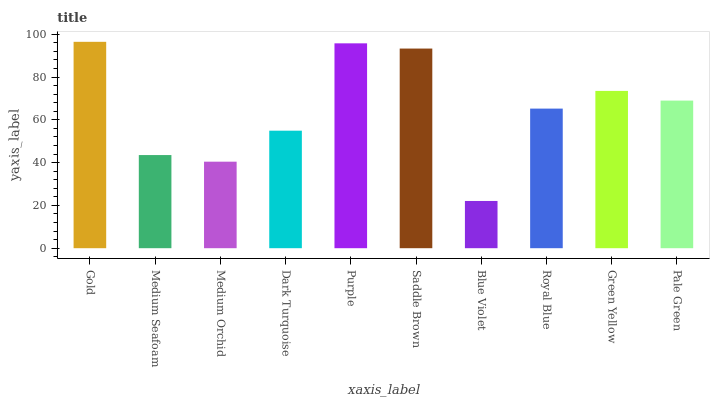Is Medium Seafoam the minimum?
Answer yes or no. No. Is Medium Seafoam the maximum?
Answer yes or no. No. Is Gold greater than Medium Seafoam?
Answer yes or no. Yes. Is Medium Seafoam less than Gold?
Answer yes or no. Yes. Is Medium Seafoam greater than Gold?
Answer yes or no. No. Is Gold less than Medium Seafoam?
Answer yes or no. No. Is Pale Green the high median?
Answer yes or no. Yes. Is Royal Blue the low median?
Answer yes or no. Yes. Is Medium Orchid the high median?
Answer yes or no. No. Is Dark Turquoise the low median?
Answer yes or no. No. 